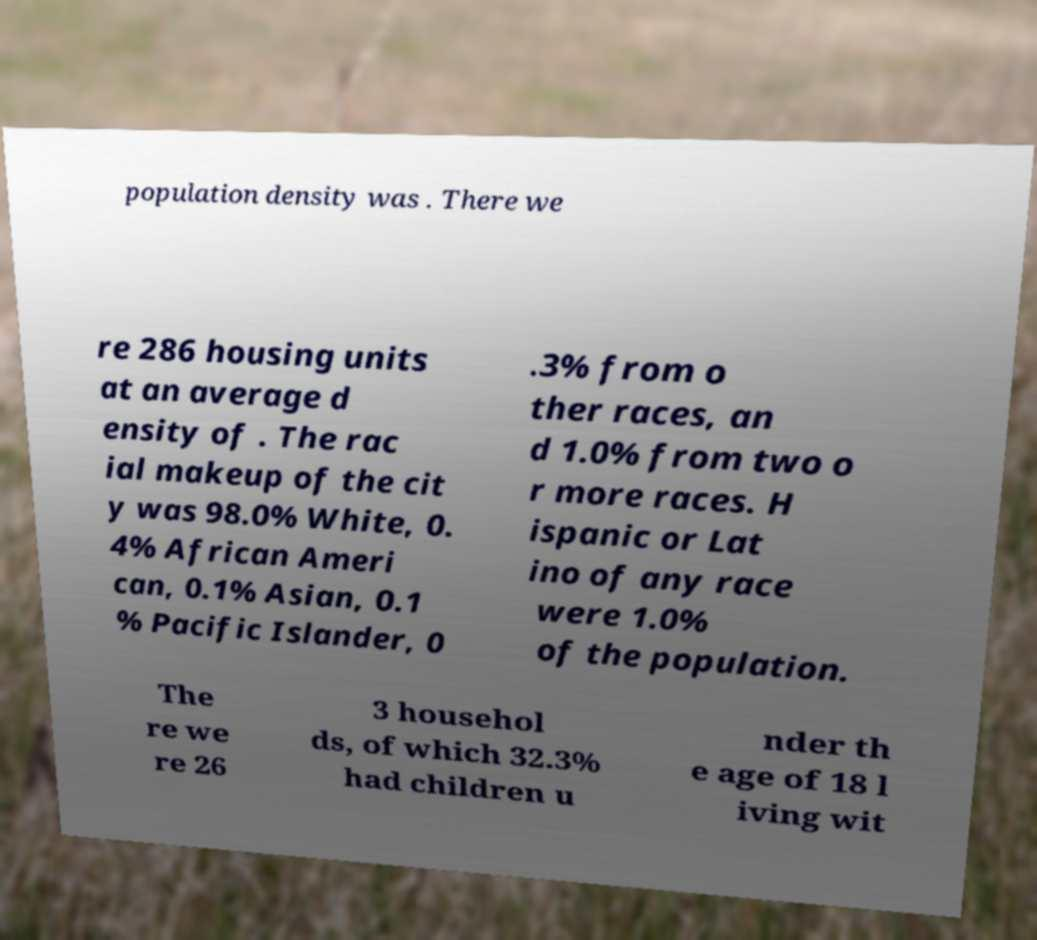Can you read and provide the text displayed in the image?This photo seems to have some interesting text. Can you extract and type it out for me? population density was . There we re 286 housing units at an average d ensity of . The rac ial makeup of the cit y was 98.0% White, 0. 4% African Ameri can, 0.1% Asian, 0.1 % Pacific Islander, 0 .3% from o ther races, an d 1.0% from two o r more races. H ispanic or Lat ino of any race were 1.0% of the population. The re we re 26 3 househol ds, of which 32.3% had children u nder th e age of 18 l iving wit 